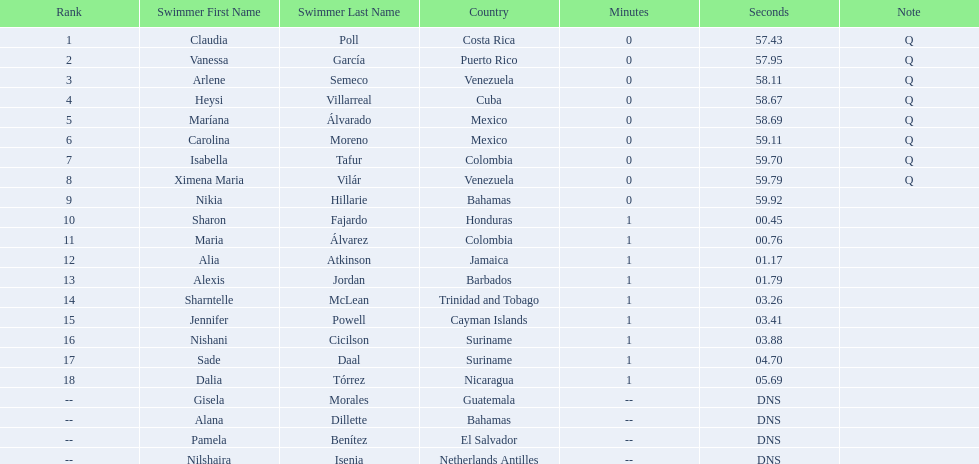Parse the full table in json format. {'header': ['Rank', 'Swimmer First Name', 'Swimmer Last Name', 'Country', 'Minutes', 'Seconds', 'Note'], 'rows': [['1', 'Claudia', 'Poll', 'Costa Rica', '0', '57.43', 'Q'], ['2', 'Vanessa', 'García', 'Puerto Rico', '0', '57.95', 'Q'], ['3', 'Arlene', 'Semeco', 'Venezuela', '0', '58.11', 'Q'], ['4', 'Heysi', 'Villarreal', 'Cuba', '0', '58.67', 'Q'], ['5', 'Maríana', 'Álvarado', 'Mexico', '0', '58.69', 'Q'], ['6', 'Carolina', 'Moreno', 'Mexico', '0', '59.11', 'Q'], ['7', 'Isabella', 'Tafur', 'Colombia', '0', '59.70', 'Q'], ['8', 'Ximena Maria', 'Vilár', 'Venezuela', '0', '59.79', 'Q'], ['9', 'Nikia', 'Hillarie', 'Bahamas', '0', '59.92', ''], ['10', 'Sharon', 'Fajardo', 'Honduras', '1', '00.45', ''], ['11', 'Maria', 'Álvarez', 'Colombia', '1', '00.76', ''], ['12', 'Alia', 'Atkinson', 'Jamaica', '1', '01.17', ''], ['13', 'Alexis', 'Jordan', 'Barbados', '1', '01.79', ''], ['14', 'Sharntelle', 'McLean', 'Trinidad and Tobago', '1', '03.26', ''], ['15', 'Jennifer', 'Powell', 'Cayman Islands', '1', '03.41', ''], ['16', 'Nishani', 'Cicilson', 'Suriname', '1', '03.88', ''], ['17', 'Sade', 'Daal', 'Suriname', '1', '04.70', ''], ['18', 'Dalia', 'Tórrez', 'Nicaragua', '1', '05.69', ''], ['--', 'Gisela', 'Morales', 'Guatemala', '--', 'DNS', ''], ['--', 'Alana', 'Dillette', 'Bahamas', '--', 'DNS', ''], ['--', 'Pamela', 'Benítez', 'El Salvador', '--', 'DNS', ''], ['--', 'Nilshaira', 'Isenia', 'Netherlands Antilles', '--', 'DNS', '']]} Who were the swimmers at the 2006 central american and caribbean games - women's 100 metre freestyle? Claudia Poll, Vanessa García, Arlene Semeco, Heysi Villarreal, Maríana Álvarado, Carolina Moreno, Isabella Tafur, Ximena Maria Vilár, Nikia Hillarie, Sharon Fajardo, Maria Álvarez, Alia Atkinson, Alexis Jordan, Sharntelle McLean, Jennifer Powell, Nishani Cicilson, Sade Daal, Dalia Tórrez, Gisela Morales, Alana Dillette, Pamela Benítez, Nilshaira Isenia. Of these which were from cuba? Heysi Villarreal. 